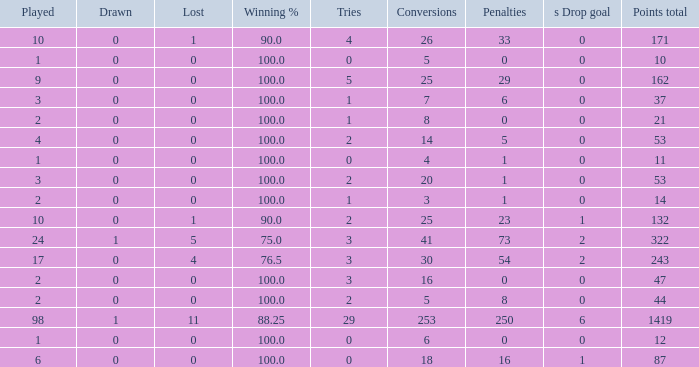What is the least number of penalties he got when his point total was over 1419 in more than 98 games? None. 